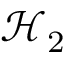Convert formula to latex. <formula><loc_0><loc_0><loc_500><loc_500>{ \mathcal { H } } _ { 2 }</formula> 